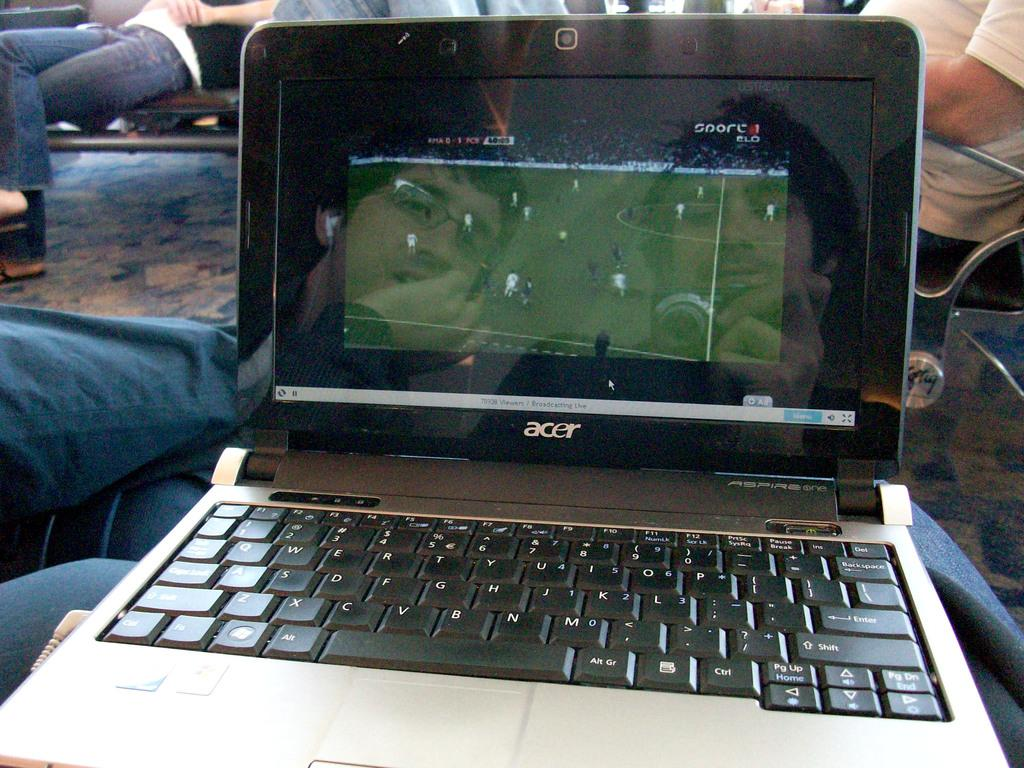<image>
Present a compact description of the photo's key features. An acer laptop is broadcasting live for a soccer match. 